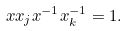<formula> <loc_0><loc_0><loc_500><loc_500>x x _ { j } x ^ { - 1 } x _ { k } ^ { - 1 } = 1 .</formula> 